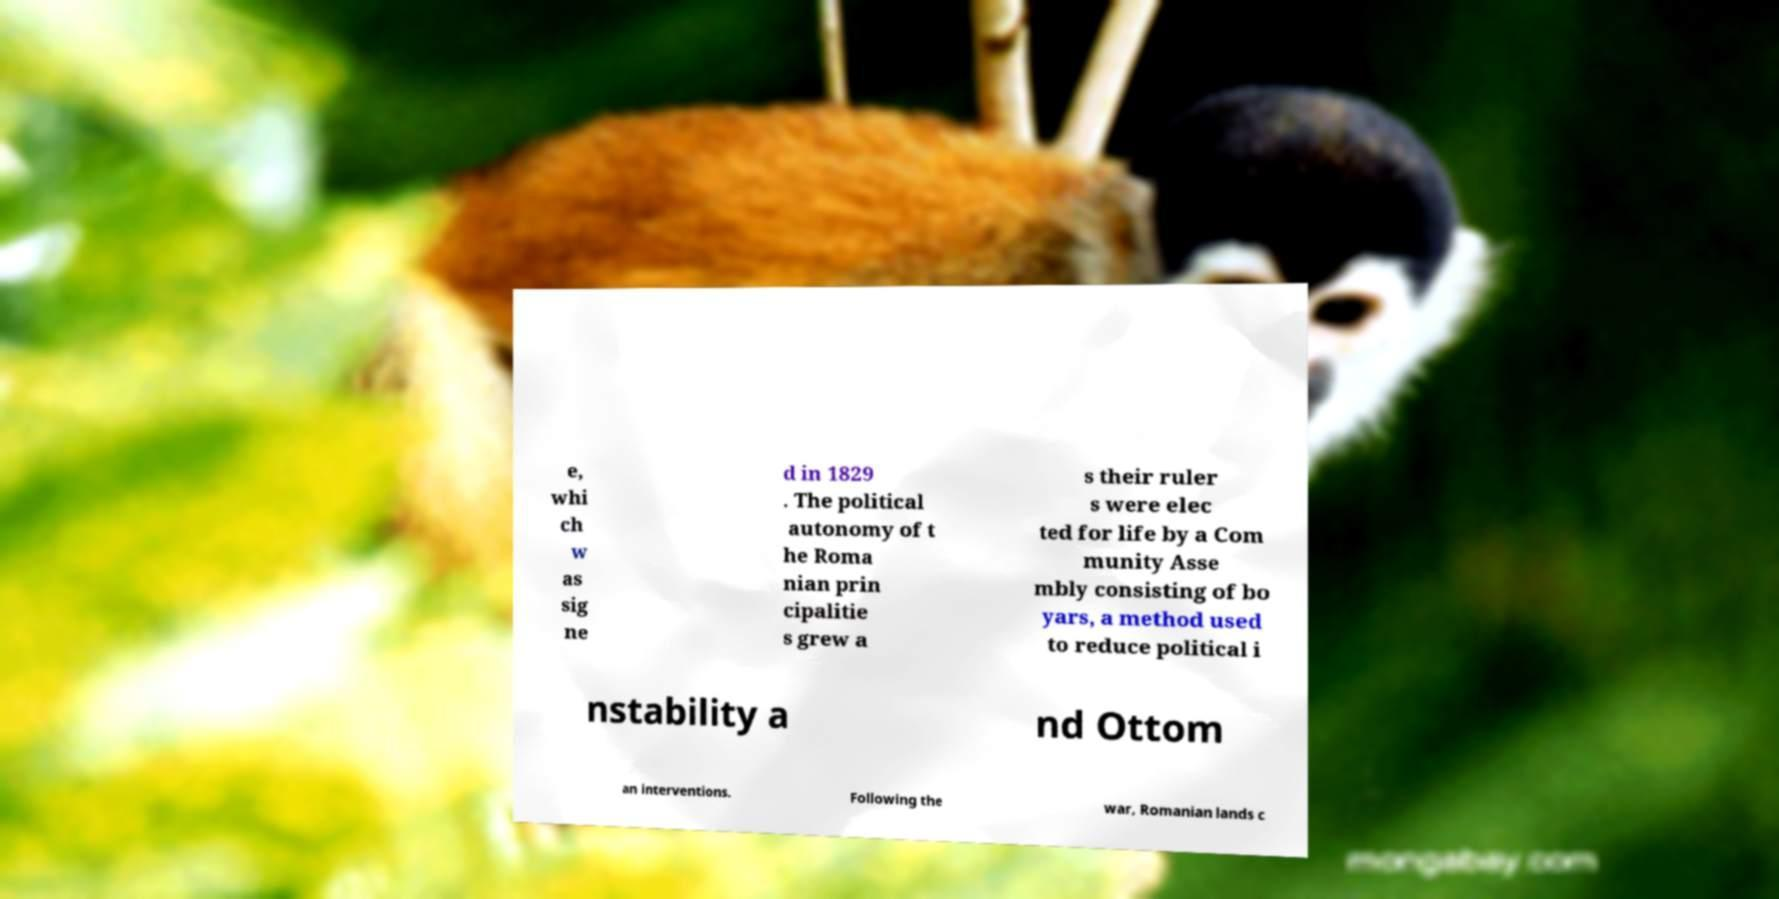Can you read and provide the text displayed in the image?This photo seems to have some interesting text. Can you extract and type it out for me? e, whi ch w as sig ne d in 1829 . The political autonomy of t he Roma nian prin cipalitie s grew a s their ruler s were elec ted for life by a Com munity Asse mbly consisting of bo yars, a method used to reduce political i nstability a nd Ottom an interventions. Following the war, Romanian lands c 